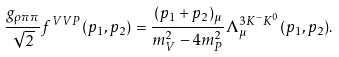<formula> <loc_0><loc_0><loc_500><loc_500>\frac { g _ { \rho \pi \pi } } { \sqrt { 2 } } f ^ { V V P } ( p _ { 1 } , p _ { 2 } ) = \frac { ( p _ { 1 } + p _ { 2 } ) _ { \mu } } { m _ { V } ^ { 2 } - 4 m _ { P } ^ { 2 } } \Lambda ^ { 3 K ^ { - } { K } ^ { 0 } } _ { \mu } ( p _ { 1 } , p _ { 2 } ) .</formula> 